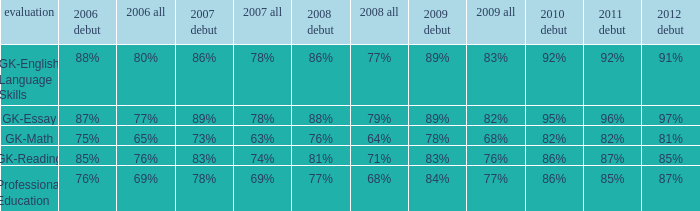Considering that the total percentage was 82% in 2009, what was the percentage for first-time occurrences in 2012? 97%. 